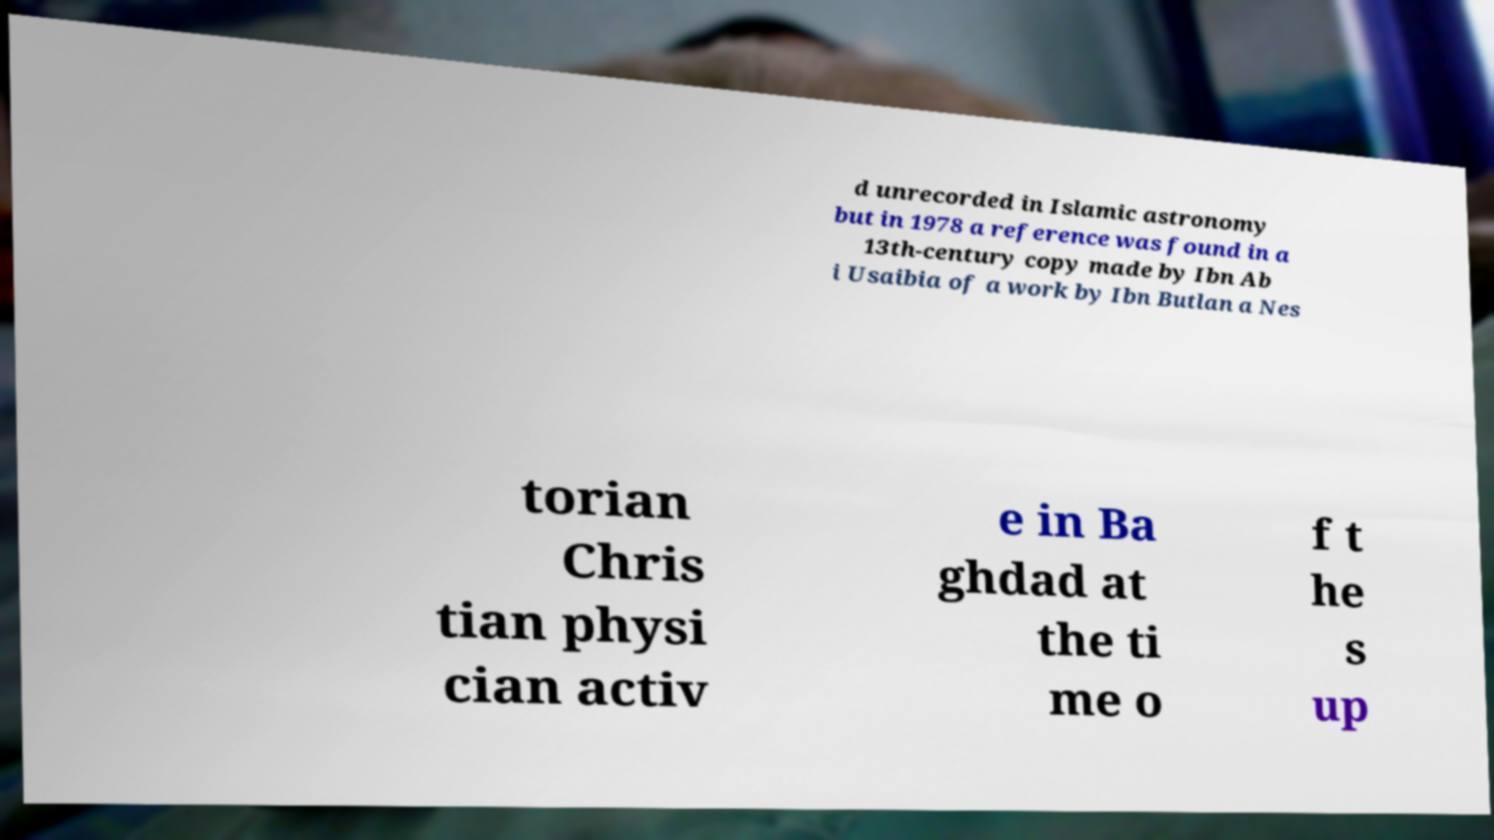Can you accurately transcribe the text from the provided image for me? d unrecorded in Islamic astronomy but in 1978 a reference was found in a 13th-century copy made by Ibn Ab i Usaibia of a work by Ibn Butlan a Nes torian Chris tian physi cian activ e in Ba ghdad at the ti me o f t he s up 